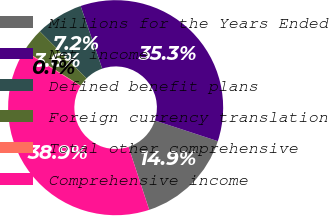Convert chart to OTSL. <chart><loc_0><loc_0><loc_500><loc_500><pie_chart><fcel>Millions for the Years Ended<fcel>Net income<fcel>Defined benefit plans<fcel>Foreign currency translation<fcel>Total other comprehensive<fcel>Comprehensive income<nl><fcel>14.91%<fcel>35.31%<fcel>7.17%<fcel>3.64%<fcel>0.11%<fcel>38.85%<nl></chart> 